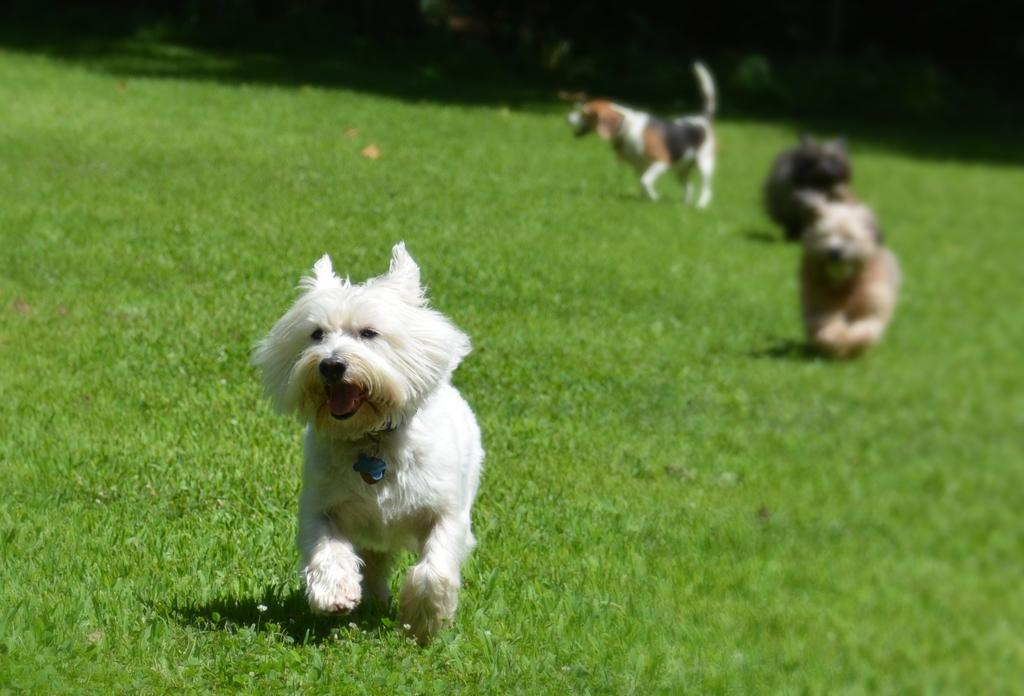How many dogs are in the image? There are three dogs in the image. What is the surface the dogs are standing on? The dogs are on grass. What other living organisms can be seen in the image? There are plants in the image. Where might this image have been taken? The image may have been taken in a park, given the presence of grass and plants. When was the image likely taken? The image was likely taken during the day, as there is sufficient light to see the dogs and plants clearly. What type of fruit is hanging from the sweater in the image? There is no sweater or fruit present in the image; it features three dogs on grass with plants in the background. 